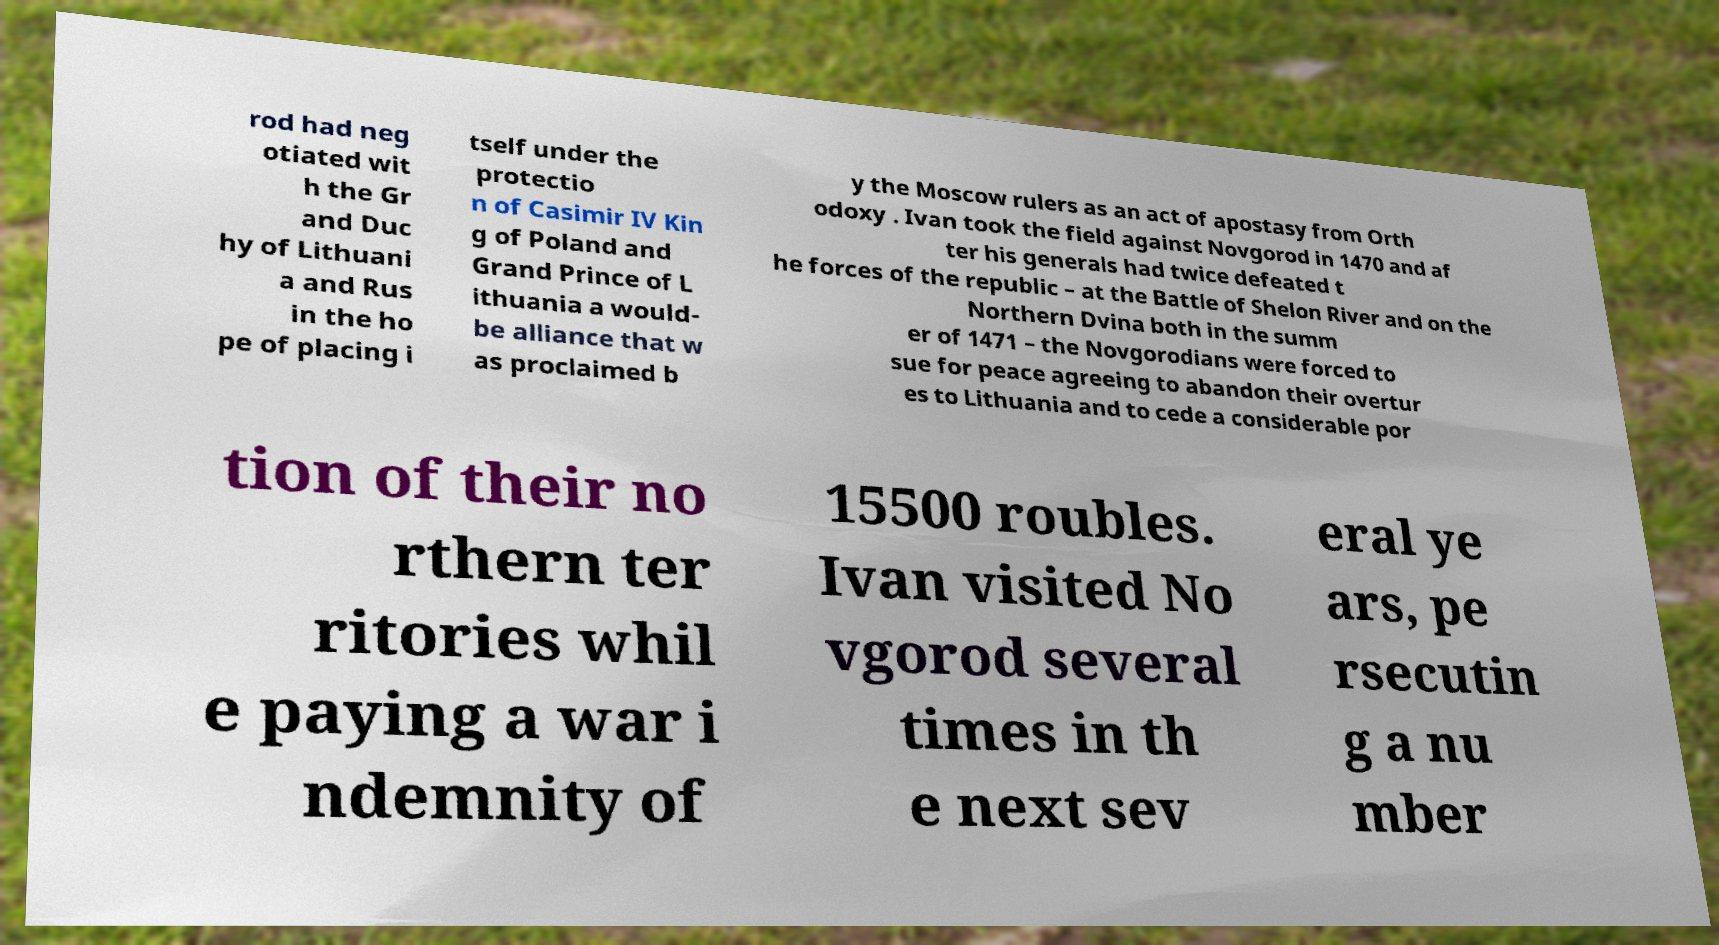There's text embedded in this image that I need extracted. Can you transcribe it verbatim? rod had neg otiated wit h the Gr and Duc hy of Lithuani a and Rus in the ho pe of placing i tself under the protectio n of Casimir IV Kin g of Poland and Grand Prince of L ithuania a would- be alliance that w as proclaimed b y the Moscow rulers as an act of apostasy from Orth odoxy . Ivan took the field against Novgorod in 1470 and af ter his generals had twice defeated t he forces of the republic – at the Battle of Shelon River and on the Northern Dvina both in the summ er of 1471 – the Novgorodians were forced to sue for peace agreeing to abandon their overtur es to Lithuania and to cede a considerable por tion of their no rthern ter ritories whil e paying a war i ndemnity of 15500 roubles. Ivan visited No vgorod several times in th e next sev eral ye ars, pe rsecutin g a nu mber 